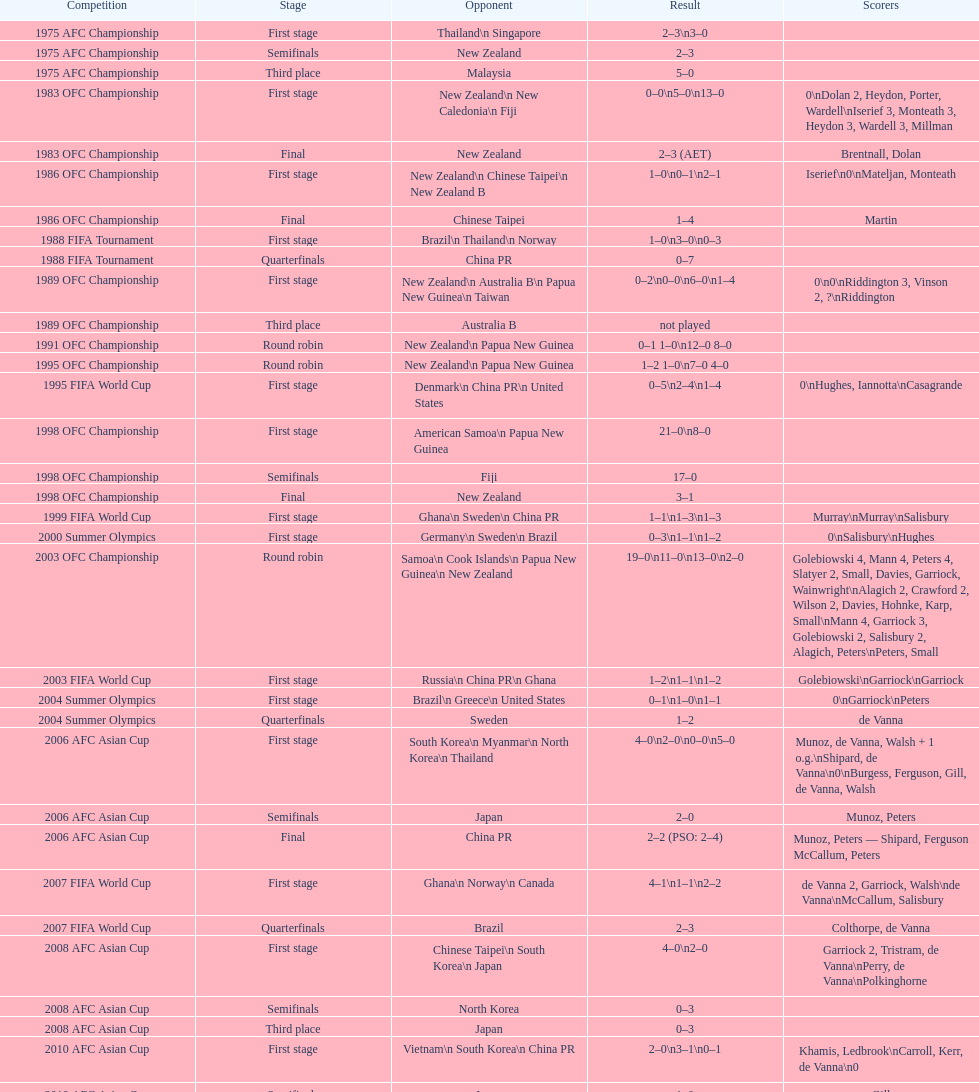What is the total number of competitions? 21. 